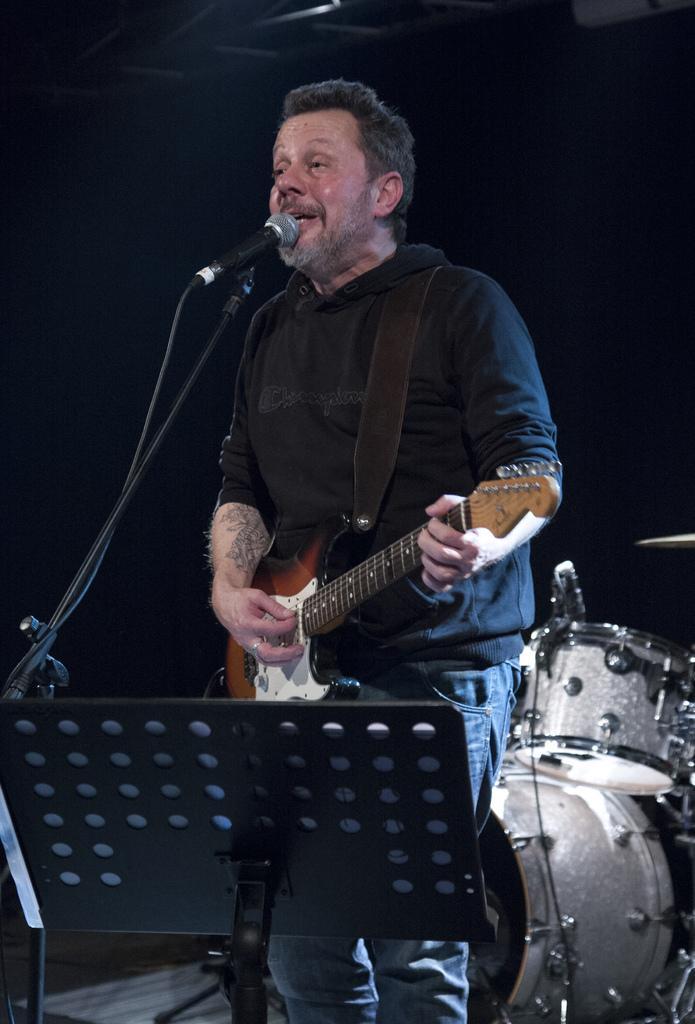Please provide a concise description of this image. This man is playing guitar and singing in-front of mic. These are musical drums. This is a mic holder. 